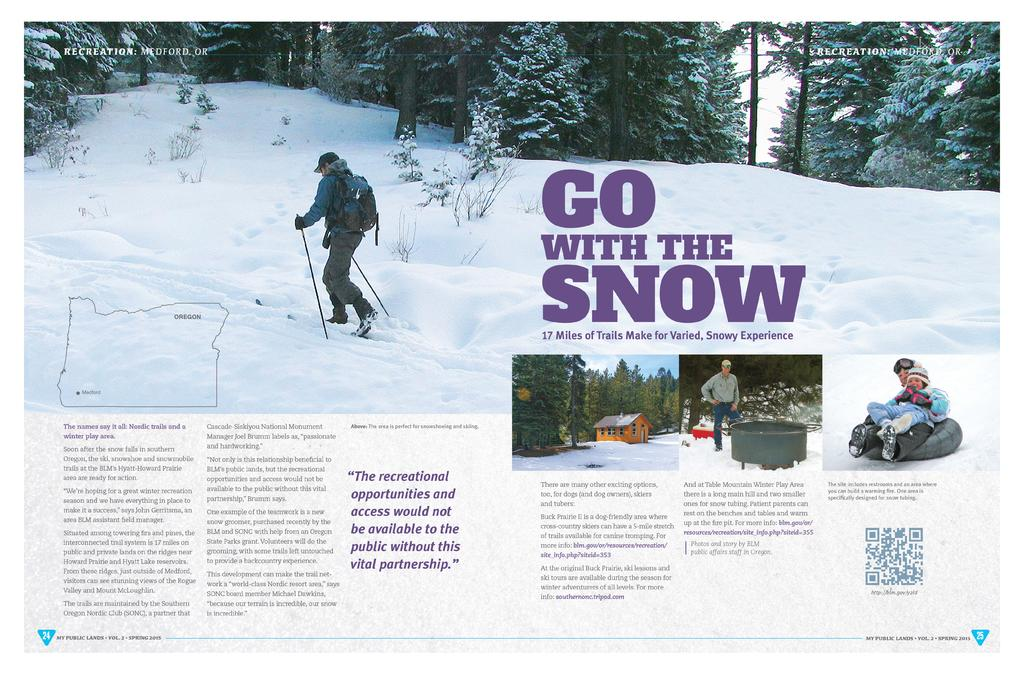What is the person in the image doing? The person in the image is trekking on snow. Is there any additional information provided with the image? Yes, there is an article related to snow below the image. What type of pan can be seen in the image? There is no pan present in the image; it features a person trekking on snow. Is there any writing visible on the snow in the image? There is no writing visible on the snow in the image. 